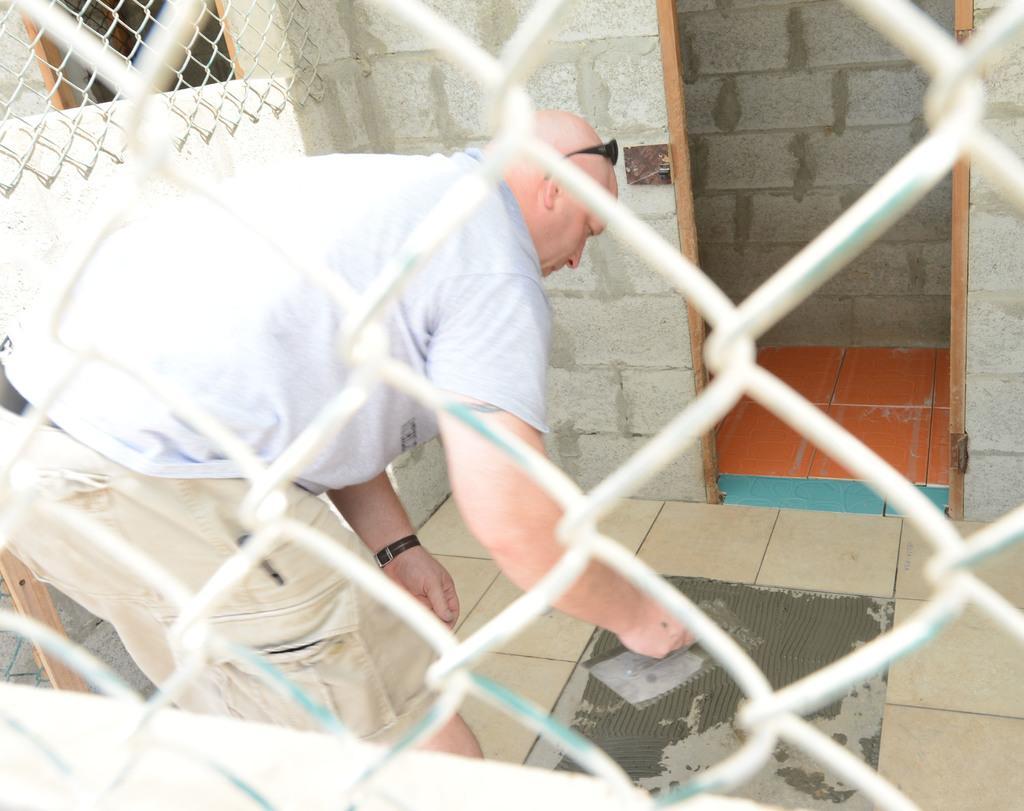In one or two sentences, can you explain what this image depicts? In the foreground there is a net. Behind the net there is a man holding an object in the hand and bending. In the background there is a room. 